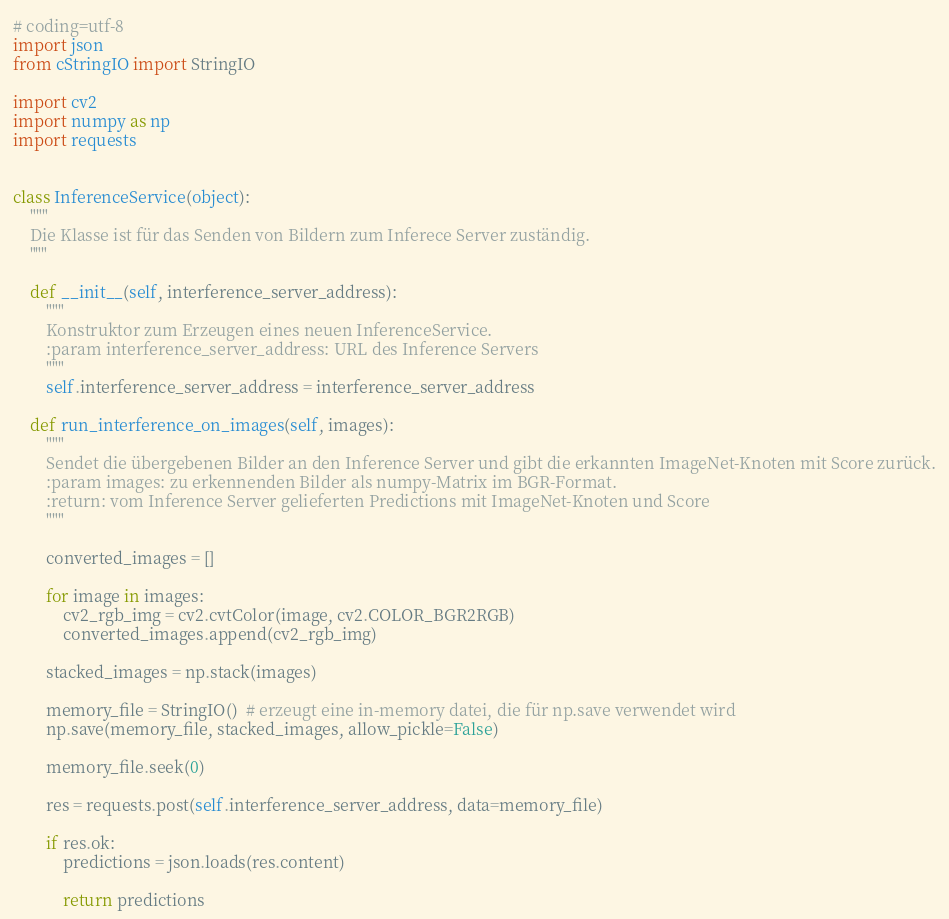Convert code to text. <code><loc_0><loc_0><loc_500><loc_500><_Python_># coding=utf-8
import json
from cStringIO import StringIO

import cv2
import numpy as np
import requests


class InferenceService(object):
    """
    Die Klasse ist für das Senden von Bildern zum Inferece Server zuständig.
    """

    def __init__(self, interference_server_address):
        """
        Konstruktor zum Erzeugen eines neuen InferenceService.
        :param interference_server_address: URL des Inference Servers
        """
        self.interference_server_address = interference_server_address

    def run_interference_on_images(self, images):
        """
        Sendet die übergebenen Bilder an den Inference Server und gibt die erkannten ImageNet-Knoten mit Score zurück.
        :param images: zu erkennenden Bilder als numpy-Matrix im BGR-Format.
        :return: vom Inference Server gelieferten Predictions mit ImageNet-Knoten und Score
        """

        converted_images = []

        for image in images:
            cv2_rgb_img = cv2.cvtColor(image, cv2.COLOR_BGR2RGB)
            converted_images.append(cv2_rgb_img)

        stacked_images = np.stack(images)

        memory_file = StringIO()  # erzeugt eine in-memory datei, die für np.save verwendet wird
        np.save(memory_file, stacked_images, allow_pickle=False)

        memory_file.seek(0)

        res = requests.post(self.interference_server_address, data=memory_file)

        if res.ok:
            predictions = json.loads(res.content)

            return predictions
</code> 